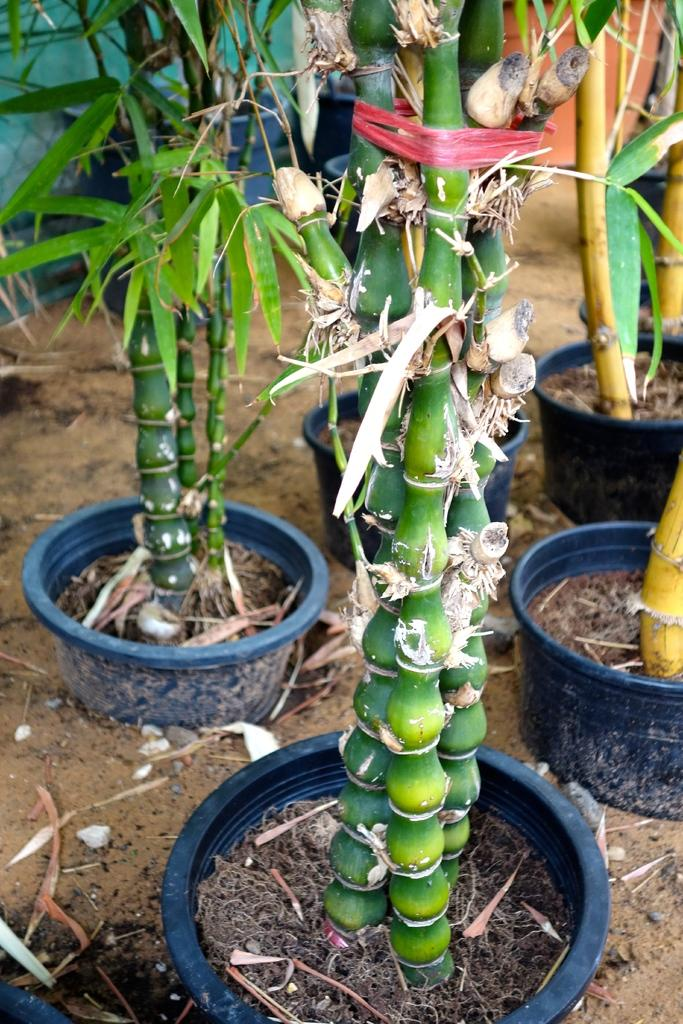What type of plants are in the image? There are plants with pots in the image. What is the surface on which the plants are placed? There is a ground visible in the image. What can be seen in the background of the image? There are unspecified objects in the background of the image. How many snails are crawling on the plants in the image? There are no snails visible in the image; it only features plants with pots and a ground. 